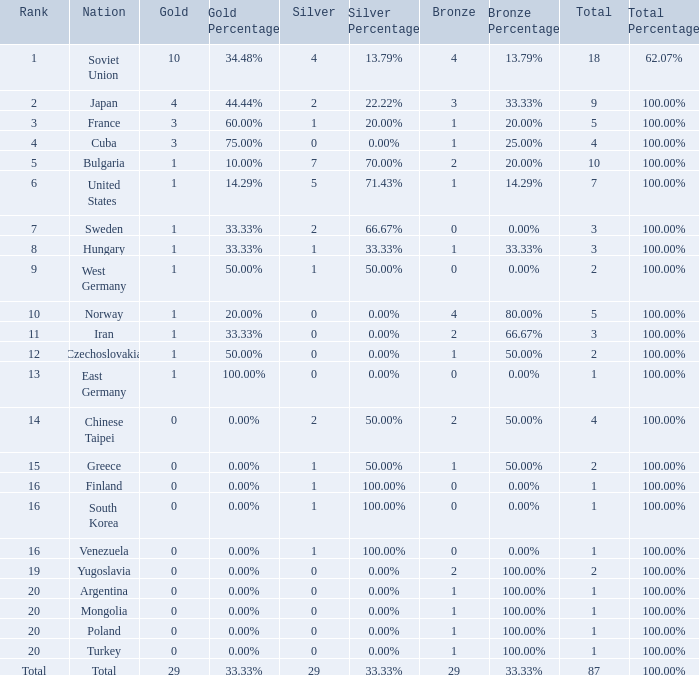Which rank has 1 silver medal and more than 1 gold medal? 3.0. 